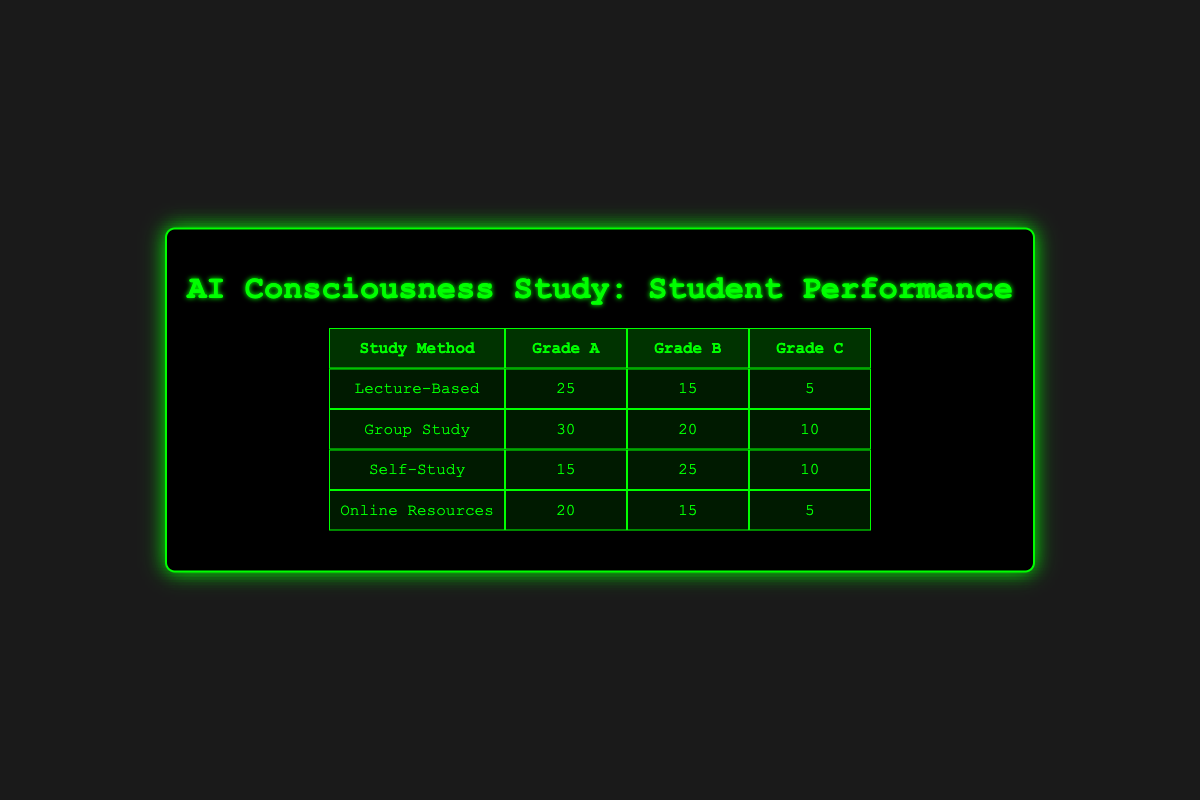What is the count of students who received Grade A using Group Study method? The table indicates that for the Group Study method, 30 students received Grade A.
Answer: 30 How many students used Self-Study and received Grade B? According to the table, 25 students received Grade B while using Self-Study.
Answer: 25 What is the total number of students who received Grade C across all study methods? To find this, we add the counts of Grade C: 5 (Lecture-Based) + 10 (Group Study) + 10 (Self-Study) + 5 (Online Resources) = 30.
Answer: 30 Which study method had the highest number of students receiving Grade B? From the table, Group Study had the highest count with 20 students receiving Grade B, compared to others.
Answer: Group Study Is it true that Online Resources had the same number of students receiving Grade A and Grade C combined? Grade A for Online Resources is 20 and Grade C is 5, together they total 25, which does not equal the number of students in either category, hence it is false.
Answer: No What is the difference between the number of students receiving Grade A and Grade C in Lecture-Based study method? For Lecture-Based, Grade A is 25 and Grade C is 5. The difference is 25 - 5 = 20.
Answer: 20 Which study method produced a total of 50 students receiving Grade A and Grade B combined? To check this, we sum the counts for Grade A and B of each method: Lecture-Based (25 + 15), Group Study (30 + 20), Self-Study (15 + 25), Online Resources (20 + 15). Only Group Study yields 50 as (30 + 20 = 50).
Answer: Group Study What is the average number of students who received Grade A across all study methods? We need to sum the counts of Grade A: 25 (Lecture-Based) + 30 (Group Study) + 15 (Self-Study) + 20 (Online Resources) = 90. Since there are 4 study methods, the average is 90/4 = 22.5.
Answer: 22.5 